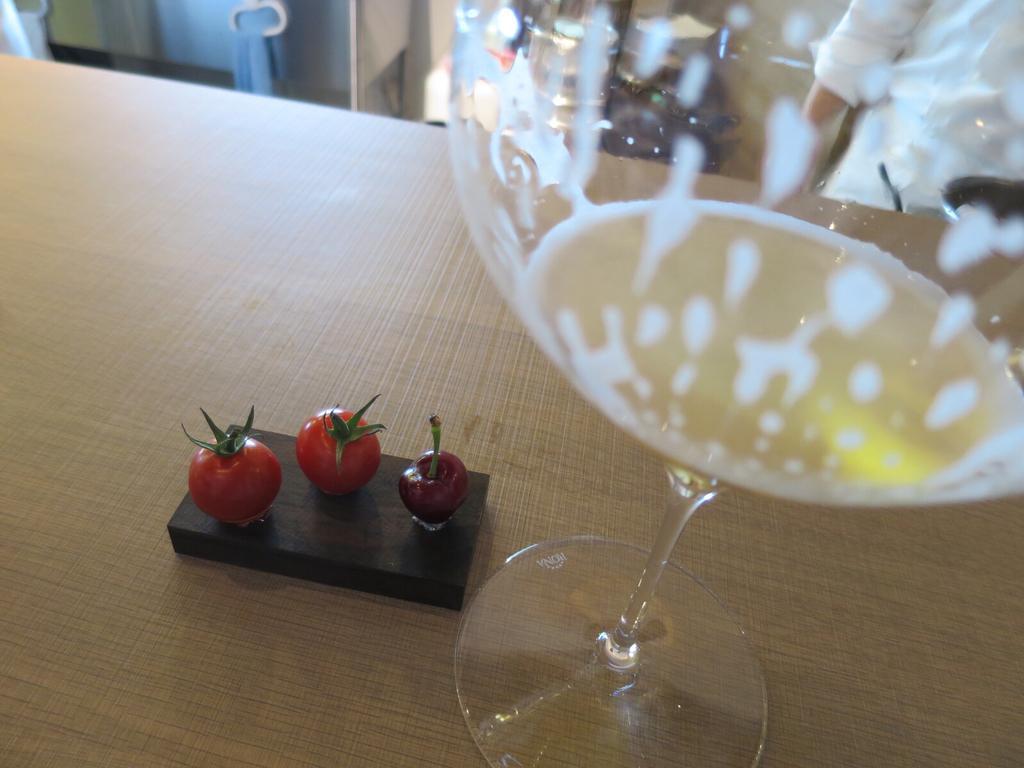How would you summarize this image in a sentence or two? As we can see in the image there is a brown color table. On table there are three strawberries and a glass. 